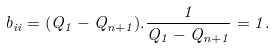<formula> <loc_0><loc_0><loc_500><loc_500>b _ { i i } = ( Q _ { 1 } - Q _ { n + 1 } ) . \frac { 1 } { Q _ { 1 } - Q _ { n + 1 } } = 1 .</formula> 